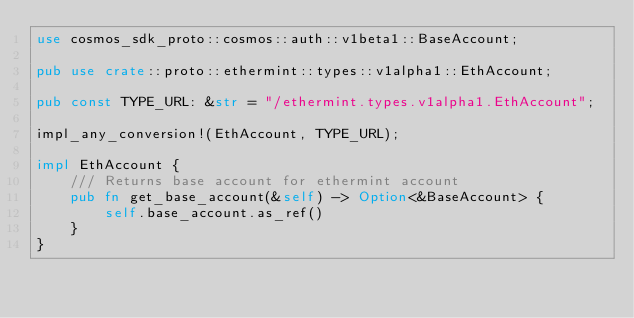<code> <loc_0><loc_0><loc_500><loc_500><_Rust_>use cosmos_sdk_proto::cosmos::auth::v1beta1::BaseAccount;

pub use crate::proto::ethermint::types::v1alpha1::EthAccount;

pub const TYPE_URL: &str = "/ethermint.types.v1alpha1.EthAccount";

impl_any_conversion!(EthAccount, TYPE_URL);

impl EthAccount {
    /// Returns base account for ethermint account
    pub fn get_base_account(&self) -> Option<&BaseAccount> {
        self.base_account.as_ref()
    }
}
</code> 